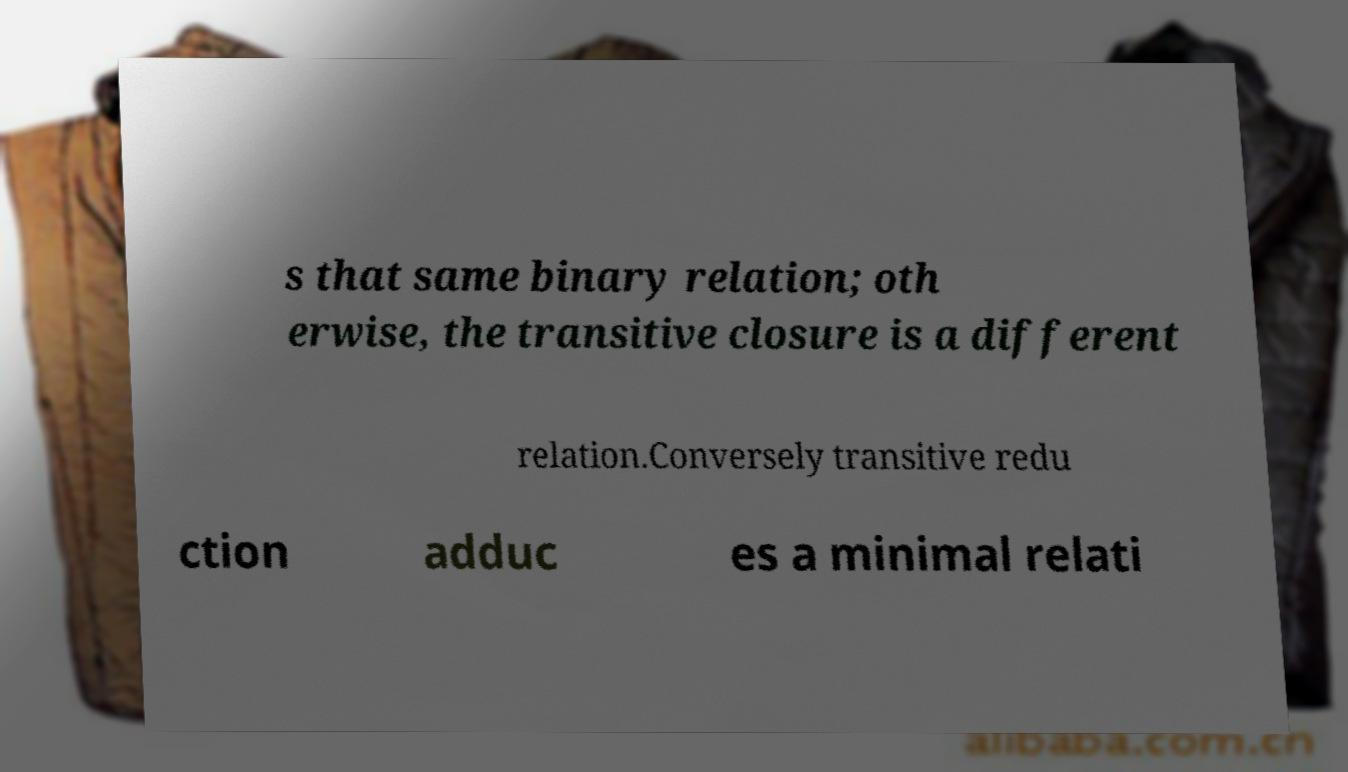Please identify and transcribe the text found in this image. s that same binary relation; oth erwise, the transitive closure is a different relation.Conversely transitive redu ction adduc es a minimal relati 